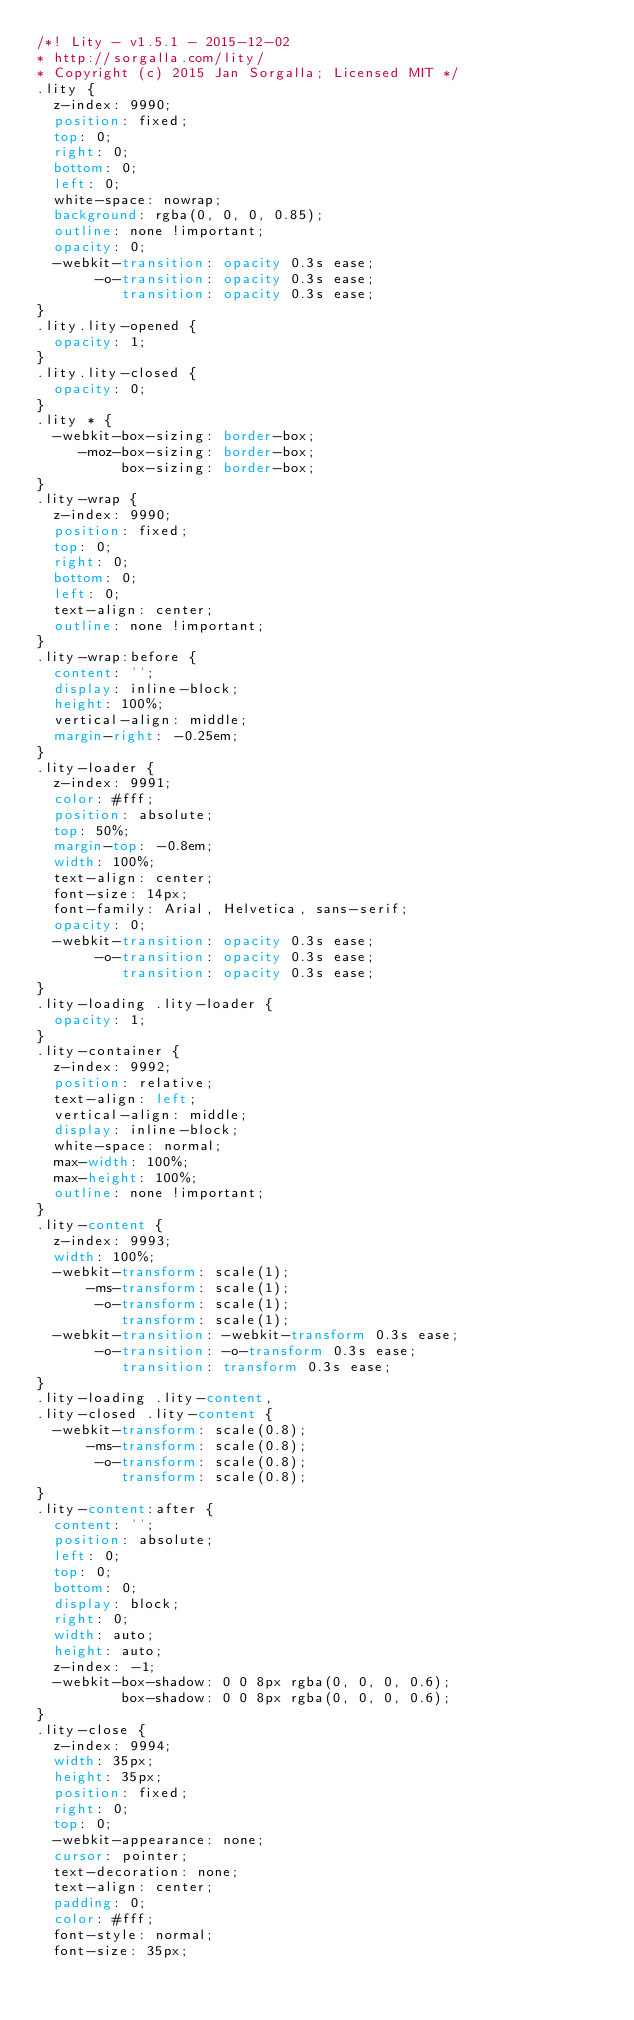Convert code to text. <code><loc_0><loc_0><loc_500><loc_500><_CSS_>/*! Lity - v1.5.1 - 2015-12-02
* http://sorgalla.com/lity/
* Copyright (c) 2015 Jan Sorgalla; Licensed MIT */
.lity {
  z-index: 9990;
  position: fixed;
  top: 0;
  right: 0;
  bottom: 0;
  left: 0;
  white-space: nowrap;
  background: rgba(0, 0, 0, 0.85);
  outline: none !important;
  opacity: 0;
  -webkit-transition: opacity 0.3s ease;
       -o-transition: opacity 0.3s ease;
          transition: opacity 0.3s ease;
}
.lity.lity-opened {
  opacity: 1;
}
.lity.lity-closed {
  opacity: 0;
}
.lity * {
  -webkit-box-sizing: border-box;
     -moz-box-sizing: border-box;
          box-sizing: border-box;
}
.lity-wrap {
  z-index: 9990;
  position: fixed;
  top: 0;
  right: 0;
  bottom: 0;
  left: 0;
  text-align: center;
  outline: none !important;
}
.lity-wrap:before {
  content: '';
  display: inline-block;
  height: 100%;
  vertical-align: middle;
  margin-right: -0.25em;
}
.lity-loader {
  z-index: 9991;
  color: #fff;
  position: absolute;
  top: 50%;
  margin-top: -0.8em;
  width: 100%;
  text-align: center;
  font-size: 14px;
  font-family: Arial, Helvetica, sans-serif;
  opacity: 0;
  -webkit-transition: opacity 0.3s ease;
       -o-transition: opacity 0.3s ease;
          transition: opacity 0.3s ease;
}
.lity-loading .lity-loader {
  opacity: 1;
}
.lity-container {
  z-index: 9992;
  position: relative;
  text-align: left;
  vertical-align: middle;
  display: inline-block;
  white-space: normal;
  max-width: 100%;
  max-height: 100%;
  outline: none !important;
}
.lity-content {
  z-index: 9993;
  width: 100%;
  -webkit-transform: scale(1);
      -ms-transform: scale(1);
       -o-transform: scale(1);
          transform: scale(1);
  -webkit-transition: -webkit-transform 0.3s ease;
       -o-transition: -o-transform 0.3s ease;
          transition: transform 0.3s ease;
}
.lity-loading .lity-content,
.lity-closed .lity-content {
  -webkit-transform: scale(0.8);
      -ms-transform: scale(0.8);
       -o-transform: scale(0.8);
          transform: scale(0.8);
}
.lity-content:after {
  content: '';
  position: absolute;
  left: 0;
  top: 0;
  bottom: 0;
  display: block;
  right: 0;
  width: auto;
  height: auto;
  z-index: -1;
  -webkit-box-shadow: 0 0 8px rgba(0, 0, 0, 0.6);
          box-shadow: 0 0 8px rgba(0, 0, 0, 0.6);
}
.lity-close {
  z-index: 9994;
  width: 35px;
  height: 35px;
  position: fixed;
  right: 0;
  top: 0;
  -webkit-appearance: none;
  cursor: pointer;
  text-decoration: none;
  text-align: center;
  padding: 0;
  color: #fff;
  font-style: normal;
  font-size: 35px;</code> 